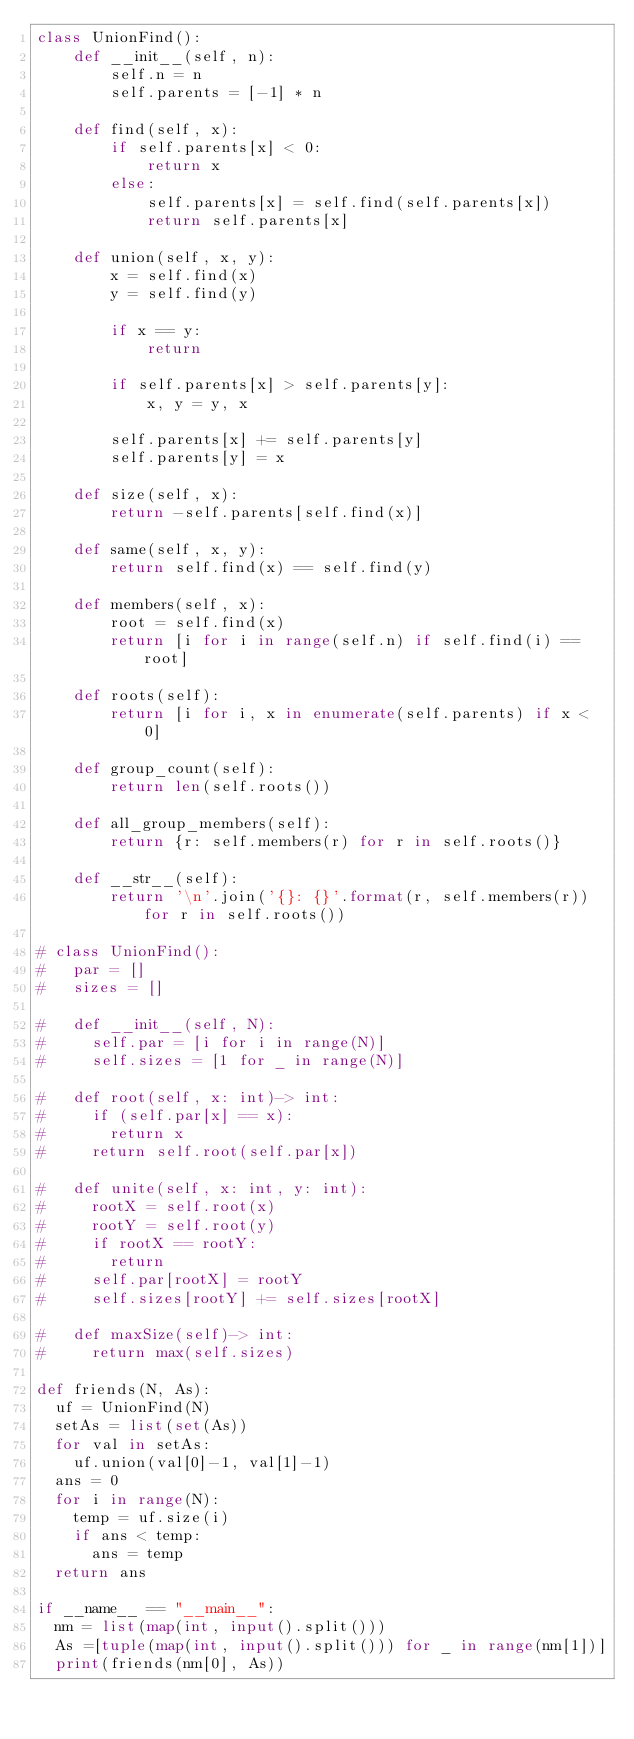<code> <loc_0><loc_0><loc_500><loc_500><_Python_>class UnionFind():
    def __init__(self, n):
        self.n = n
        self.parents = [-1] * n

    def find(self, x):
        if self.parents[x] < 0:
            return x
        else:
            self.parents[x] = self.find(self.parents[x])
            return self.parents[x]

    def union(self, x, y):
        x = self.find(x)
        y = self.find(y)

        if x == y:
            return

        if self.parents[x] > self.parents[y]:
            x, y = y, x

        self.parents[x] += self.parents[y]
        self.parents[y] = x

    def size(self, x):
        return -self.parents[self.find(x)]

    def same(self, x, y):
        return self.find(x) == self.find(y)

    def members(self, x):
        root = self.find(x)
        return [i for i in range(self.n) if self.find(i) == root]

    def roots(self):
        return [i for i, x in enumerate(self.parents) if x < 0]

    def group_count(self):
        return len(self.roots())

    def all_group_members(self):
        return {r: self.members(r) for r in self.roots()}

    def __str__(self):
        return '\n'.join('{}: {}'.format(r, self.members(r)) for r in self.roots())

# class UnionFind():
#   par = []
#   sizes = []

#   def __init__(self, N):
#     self.par = [i for i in range(N)]
#     self.sizes = [1 for _ in range(N)]

#   def root(self, x: int)-> int:
#     if (self.par[x] == x):
#       return x
#     return self.root(self.par[x])

#   def unite(self, x: int, y: int):
#     rootX = self.root(x)
#     rootY = self.root(y)
#     if rootX == rootY:
#       return
#     self.par[rootX] = rootY
#     self.sizes[rootY] += self.sizes[rootX]

#   def maxSize(self)-> int:
#     return max(self.sizes)

def friends(N, As):
  uf = UnionFind(N)
  setAs = list(set(As))
  for val in setAs:
    uf.union(val[0]-1, val[1]-1)
  ans = 0
  for i in range(N):
    temp = uf.size(i)
    if ans < temp:
      ans = temp
  return ans

if __name__ == "__main__":
  nm = list(map(int, input().split()))
  As =[tuple(map(int, input().split())) for _ in range(nm[1])]
  print(friends(nm[0], As))</code> 